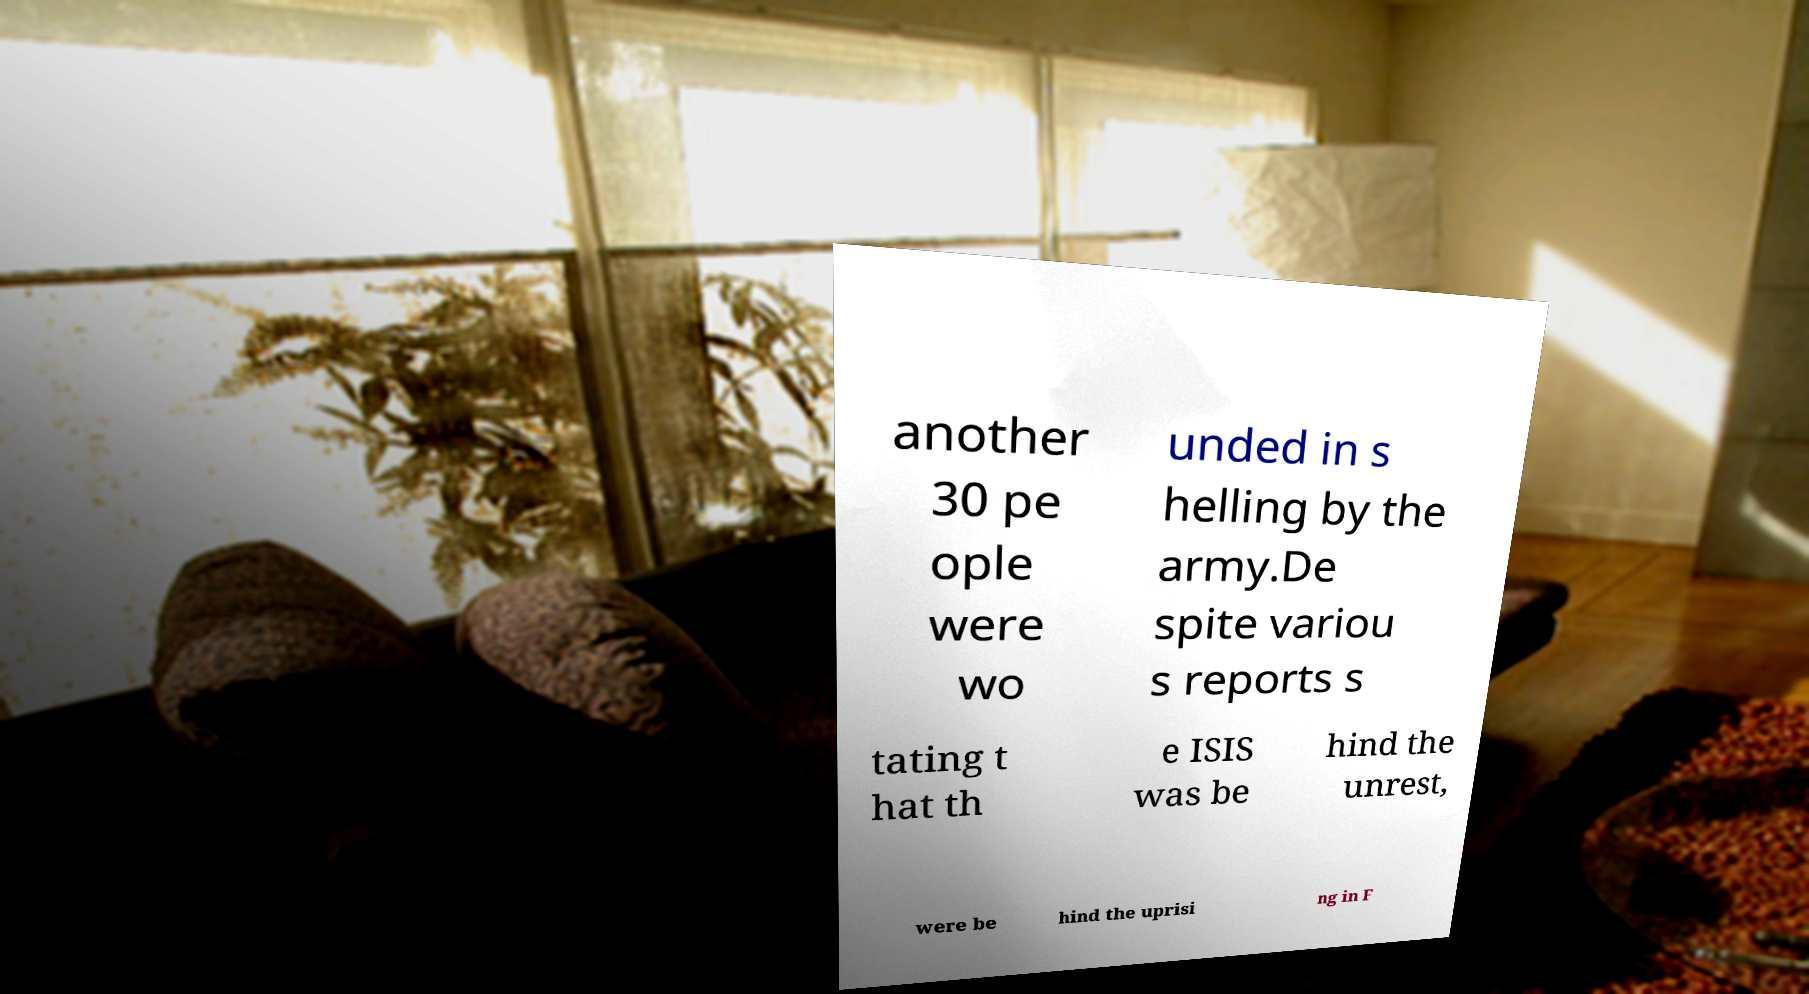For documentation purposes, I need the text within this image transcribed. Could you provide that? another 30 pe ople were wo unded in s helling by the army.De spite variou s reports s tating t hat th e ISIS was be hind the unrest, were be hind the uprisi ng in F 